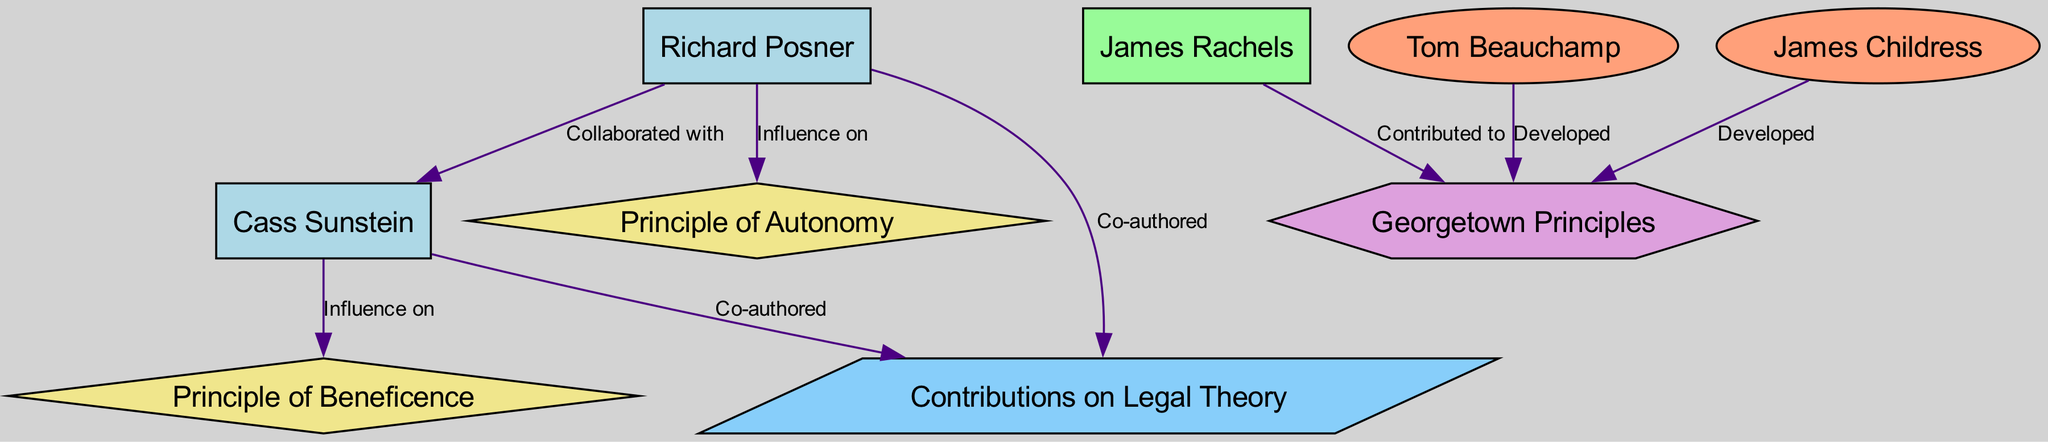What is the role of Richard Posner in the diagram? The diagram shows Richard Posner identified as a "Law Professor," confirming his academic position within the structure.
Answer: Law Professor How many nodes are there representing bioethics principles? The diagram includes two nodes explicitly labeled as "Bioethics Principle," namely the Principle of Autonomy and the Principle of Beneficence.
Answer: 2 Who developed the Georgetown Principles? The diagram lists both Tom Beauchamp and James Childress, indicating their contributions in the development of the Georgetown Principles.
Answer: Tom Beauchamp, James Childress Which law professor collaborated with Cass Sunstein? The diagram connects Richard Posner to Cass Sunstein with an edge labeled "Collaborated with," confirming his collaboration with the law professor.
Answer: Richard Posner What type of research is represented by the edge labeled "Contributions on Legal Theory"? The edge named "Contributions on Legal Theory" is linked to both Richard Posner and Cass Sunstein, indicating their collaborative research efforts in legal theory.
Answer: Collaborative Research How many collaborations are shown in the diagram? By analyzing the edges, there are two distinct collaborations: one between Richard Posner and Cass Sunstein on legal theory, and another co-authored contribution by the same professors.
Answer: 2 Which principle does Cass Sunstein influence? The diagram indicates that Cass Sunstein has an influence on the "Principle of Beneficence," explicitly showing his connection to this bioethics principle.
Answer: Principle of Beneficence What shape represents the Bioethics Framework in the diagram? The Georgetown Principles node is depicted in a hexagon shape, specifically used for denoting the Bioethics Framework in this diagram.
Answer: Hexagon 